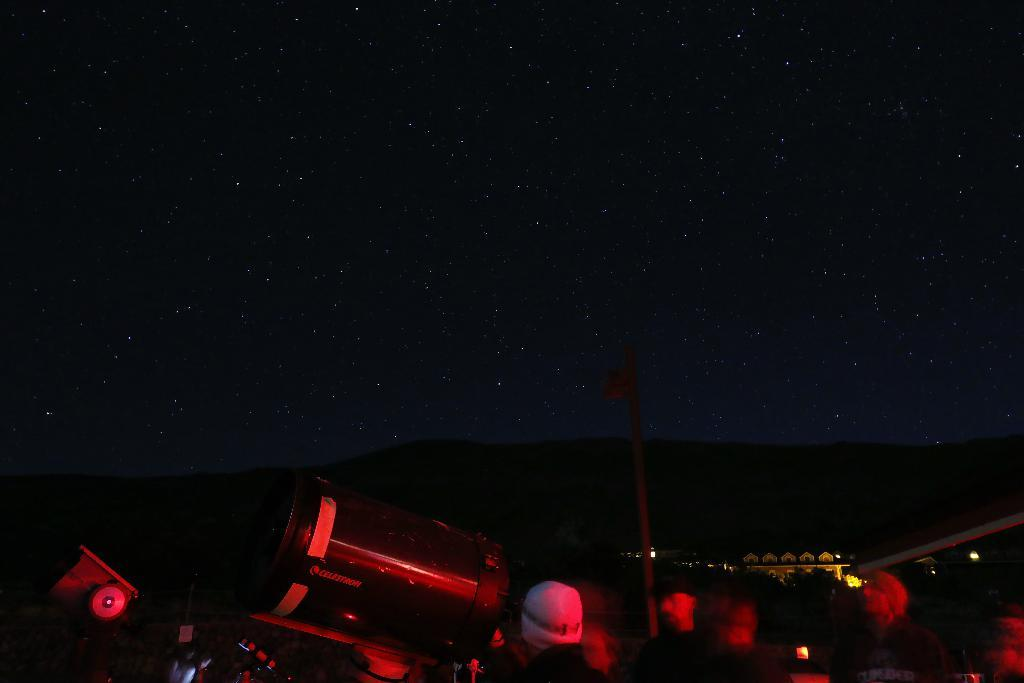What is located in the foreground of the image? There are persons and an object in the foreground of the image. What else can be seen in the foreground of the image? There is a pole in the foreground of the image. What is visible in the background of the image? The sky is visible in the image. Can you describe the sky in the image? The sky is dark, and stars are visible in the sky. What type of rhythm does the committee perform in the image? There is no committee or rhythm present in the image. Are there any bushes visible in the image? There is no mention of bushes in the provided facts, so we cannot determine if they are present in the image. 